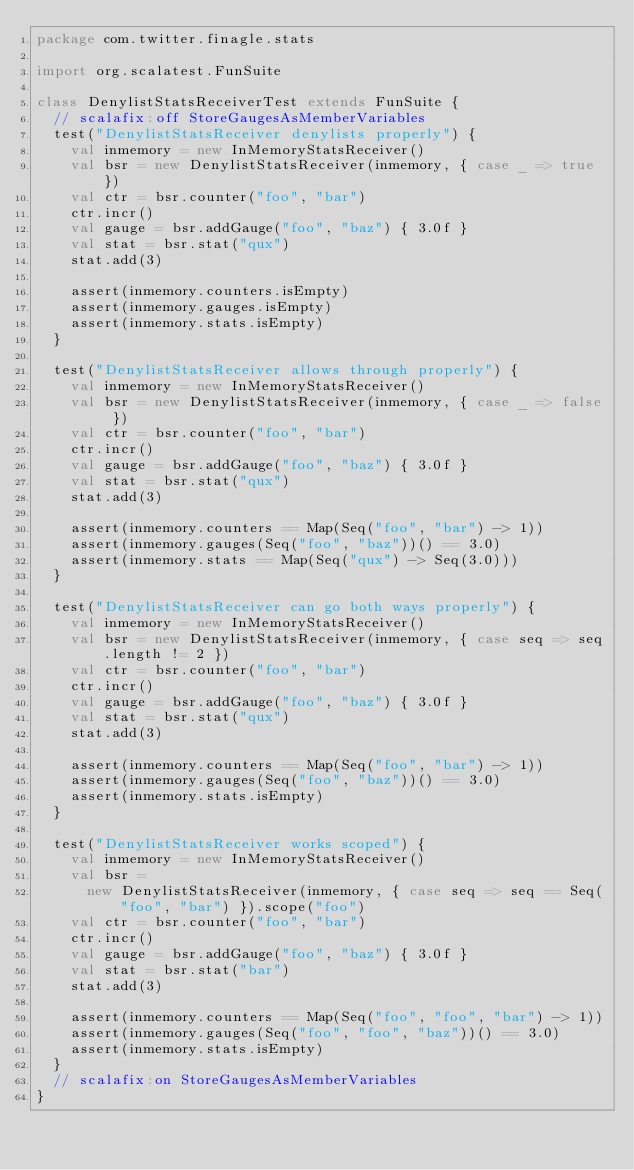Convert code to text. <code><loc_0><loc_0><loc_500><loc_500><_Scala_>package com.twitter.finagle.stats

import org.scalatest.FunSuite

class DenylistStatsReceiverTest extends FunSuite {
  // scalafix:off StoreGaugesAsMemberVariables
  test("DenylistStatsReceiver denylists properly") {
    val inmemory = new InMemoryStatsReceiver()
    val bsr = new DenylistStatsReceiver(inmemory, { case _ => true })
    val ctr = bsr.counter("foo", "bar")
    ctr.incr()
    val gauge = bsr.addGauge("foo", "baz") { 3.0f }
    val stat = bsr.stat("qux")
    stat.add(3)

    assert(inmemory.counters.isEmpty)
    assert(inmemory.gauges.isEmpty)
    assert(inmemory.stats.isEmpty)
  }

  test("DenylistStatsReceiver allows through properly") {
    val inmemory = new InMemoryStatsReceiver()
    val bsr = new DenylistStatsReceiver(inmemory, { case _ => false })
    val ctr = bsr.counter("foo", "bar")
    ctr.incr()
    val gauge = bsr.addGauge("foo", "baz") { 3.0f }
    val stat = bsr.stat("qux")
    stat.add(3)

    assert(inmemory.counters == Map(Seq("foo", "bar") -> 1))
    assert(inmemory.gauges(Seq("foo", "baz"))() == 3.0)
    assert(inmemory.stats == Map(Seq("qux") -> Seq(3.0)))
  }

  test("DenylistStatsReceiver can go both ways properly") {
    val inmemory = new InMemoryStatsReceiver()
    val bsr = new DenylistStatsReceiver(inmemory, { case seq => seq.length != 2 })
    val ctr = bsr.counter("foo", "bar")
    ctr.incr()
    val gauge = bsr.addGauge("foo", "baz") { 3.0f }
    val stat = bsr.stat("qux")
    stat.add(3)

    assert(inmemory.counters == Map(Seq("foo", "bar") -> 1))
    assert(inmemory.gauges(Seq("foo", "baz"))() == 3.0)
    assert(inmemory.stats.isEmpty)
  }

  test("DenylistStatsReceiver works scoped") {
    val inmemory = new InMemoryStatsReceiver()
    val bsr =
      new DenylistStatsReceiver(inmemory, { case seq => seq == Seq("foo", "bar") }).scope("foo")
    val ctr = bsr.counter("foo", "bar")
    ctr.incr()
    val gauge = bsr.addGauge("foo", "baz") { 3.0f }
    val stat = bsr.stat("bar")
    stat.add(3)

    assert(inmemory.counters == Map(Seq("foo", "foo", "bar") -> 1))
    assert(inmemory.gauges(Seq("foo", "foo", "baz"))() == 3.0)
    assert(inmemory.stats.isEmpty)
  }
  // scalafix:on StoreGaugesAsMemberVariables
}
</code> 